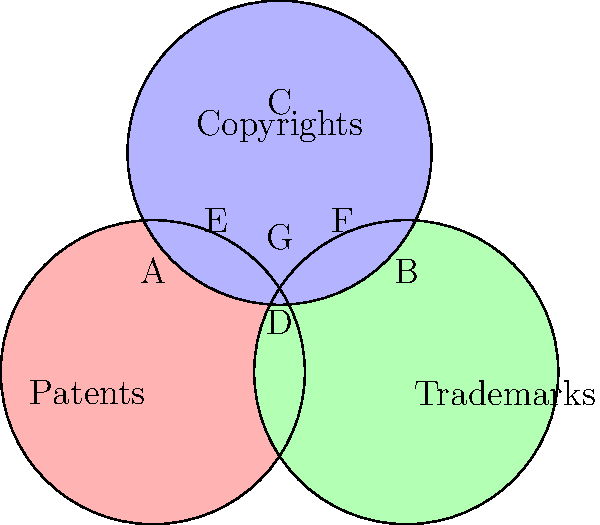In the Venn diagram above, three main categories of intellectual property protection (Patents, Trademarks, and Copyrights) are represented across different jurisdictions. If region G represents subject matter that can be protected by all three categories in at least one jurisdiction, which region represents subject matter that can only be protected by both Patents and Trademarks, but not Copyrights, in at least one jurisdiction? To answer this question, we need to analyze the Venn diagram and understand what each region represents:

1. The red circle represents Patents.
2. The green circle represents Trademarks.
3. The blue circle represents Copyrights.
4. Region A is exclusively within the Patents circle.
5. Region B is exclusively within the Trademarks circle.
6. Region C is exclusively within the Copyrights circle.
7. Region D is the overlap between Patents and Trademarks, but not Copyrights.
8. Region E is the overlap between Patents and Copyrights, but not Trademarks.
9. Region F is the overlap between Trademarks and Copyrights, but not Patents.
10. Region G is the overlap of all three circles, representing subject matter that can be protected by all three categories.

The question asks for the region that represents subject matter protected by both Patents and Trademarks, but not Copyrights. This description matches Region D, which is the overlap between the Patents and Trademarks circles, excluding the area where Copyrights also intersect.
Answer: D 